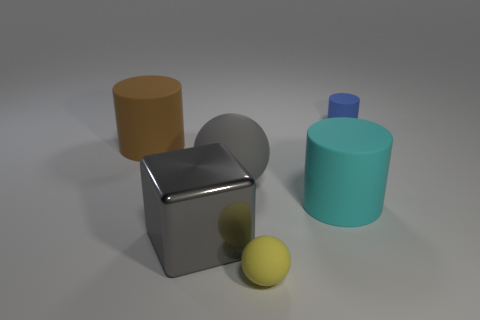Subtract 1 cylinders. How many cylinders are left? 2 Add 1 small gray rubber cubes. How many objects exist? 7 Subtract all cubes. How many objects are left? 5 Subtract 0 purple spheres. How many objects are left? 6 Subtract all large gray shiny spheres. Subtract all blue things. How many objects are left? 5 Add 1 metallic cubes. How many metallic cubes are left? 2 Add 4 large cyan cylinders. How many large cyan cylinders exist? 5 